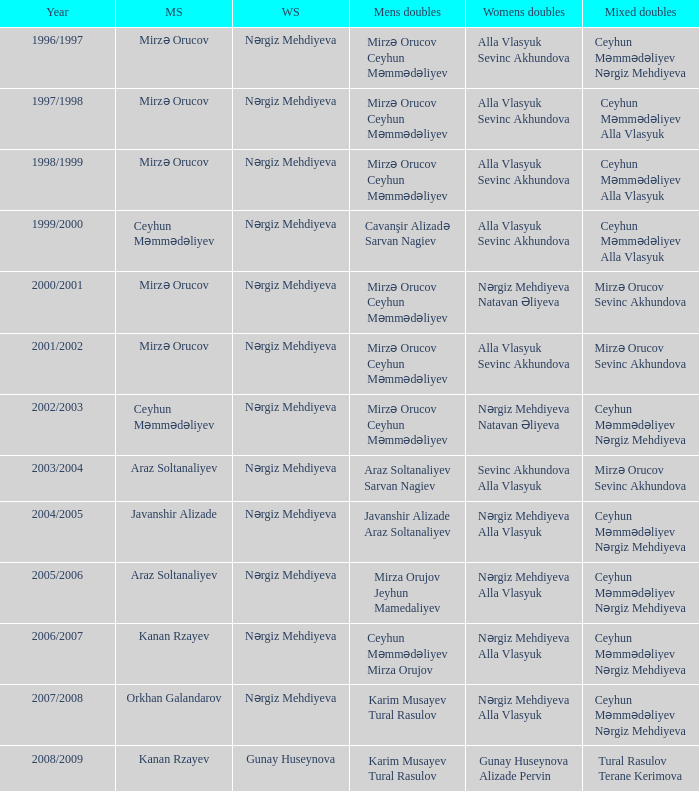Who are all the womens doubles for the year 2008/2009? Gunay Huseynova Alizade Pervin. 